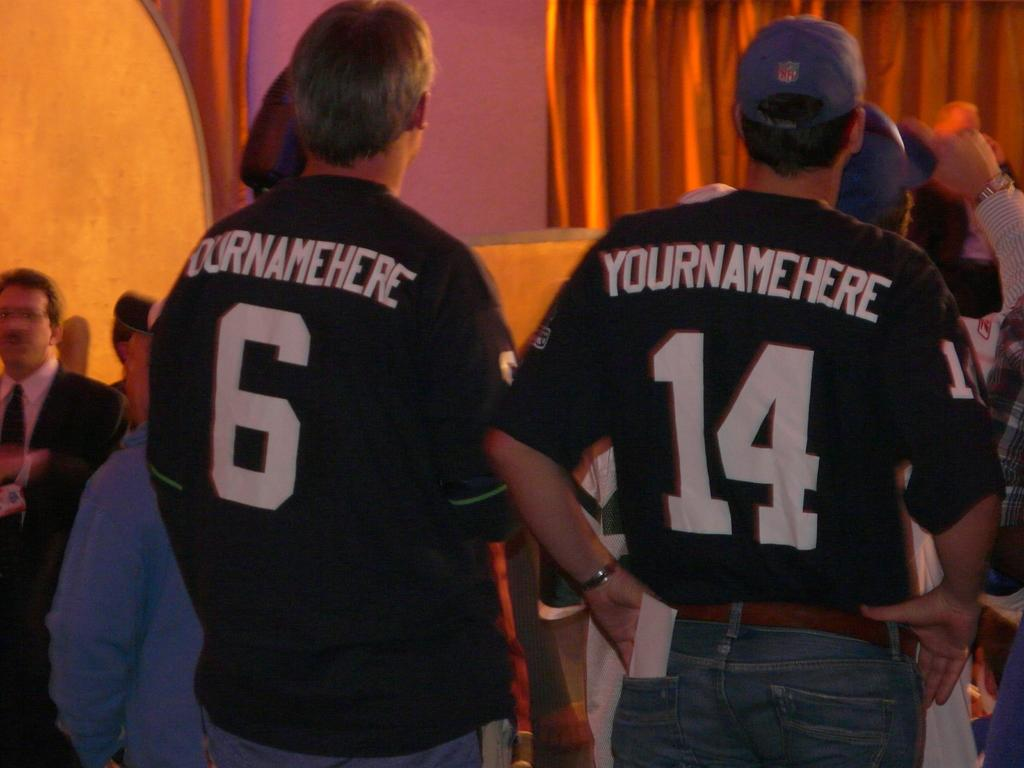<image>
Present a compact description of the photo's key features. Two people wearing jerseys with YOURNAMEHERE on the back at an event. 